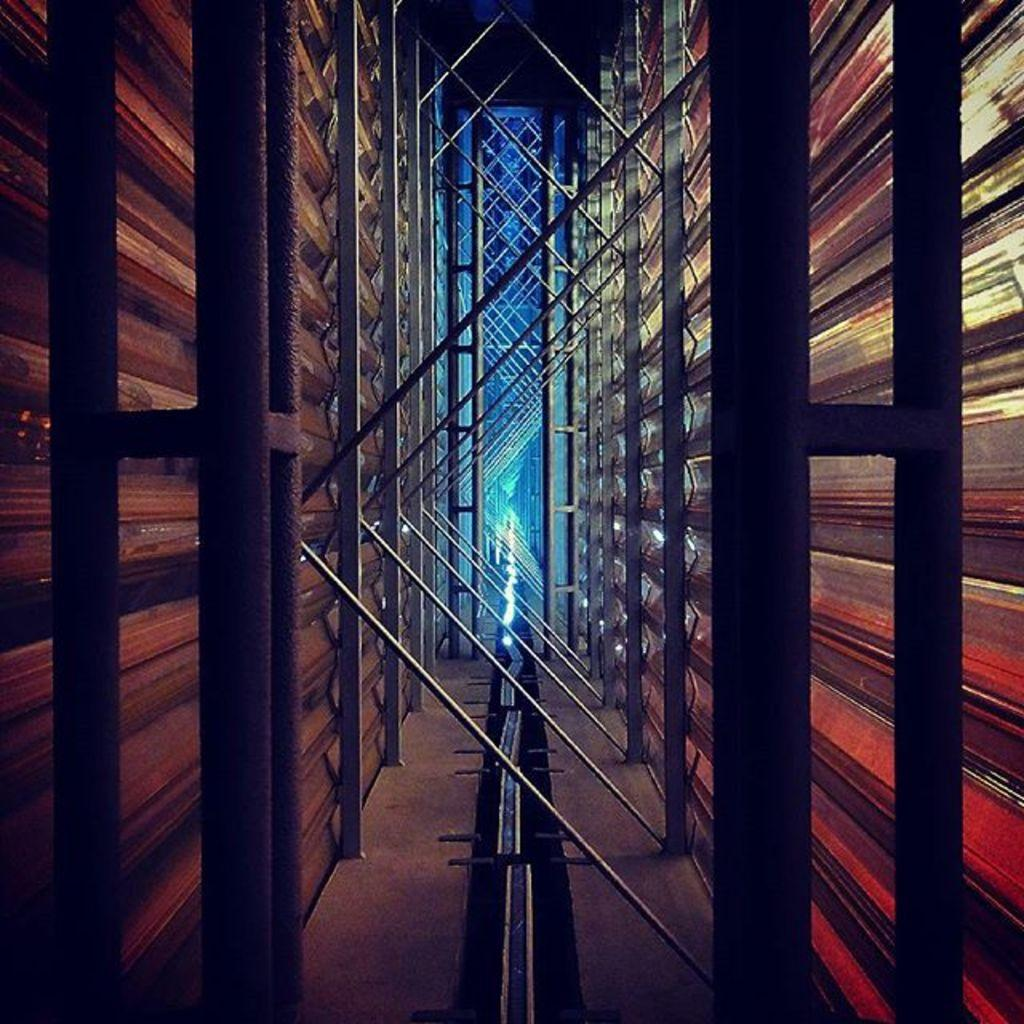What can be seen on the left side of the image? There are poles on the left side of the image. What is located on the right side of the image? There are poles on the right side of the image. What is present on the floor in the image? Metal sheets are present on the floor. What is the arrangement of the poles in the middle of the image? The poles in the middle of the image are arranged in a random order. What type of reward is being given to the writer in the image? There is no writer or reward present in the image; it only features poles and metal sheets. 